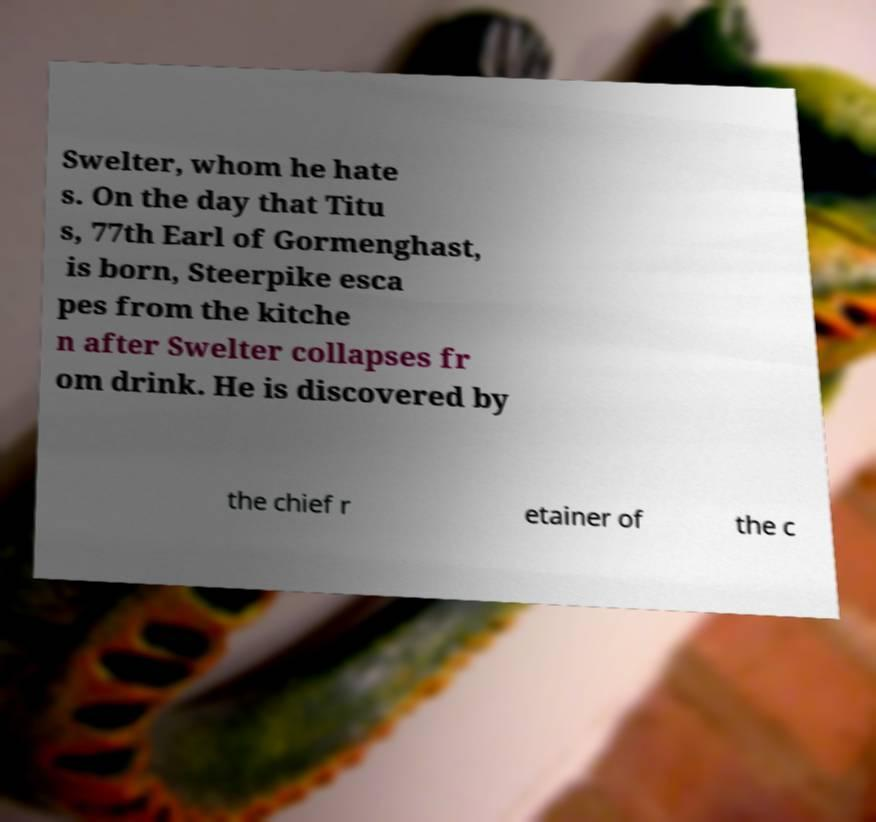Could you assist in decoding the text presented in this image and type it out clearly? Swelter, whom he hate s. On the day that Titu s, 77th Earl of Gormenghast, is born, Steerpike esca pes from the kitche n after Swelter collapses fr om drink. He is discovered by the chief r etainer of the c 